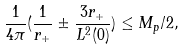Convert formula to latex. <formula><loc_0><loc_0><loc_500><loc_500>\frac { 1 } { 4 \pi } ( \frac { 1 } { r _ { + } } \pm \frac { 3 r _ { + } } { L ^ { 2 } ( 0 ) } ) \leq M _ { p } / 2 ,</formula> 